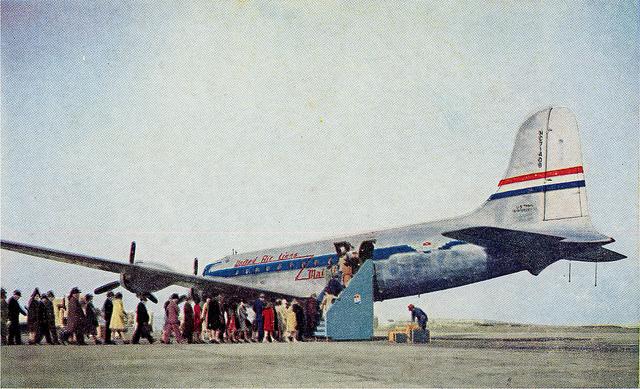Do people board planes this way today?
Quick response, please. No. How do you know this is a vintage photo?
Give a very brief answer. Weathered, people's clothes. Is there a long line of people to board the plane?
Be succinct. Yes. 